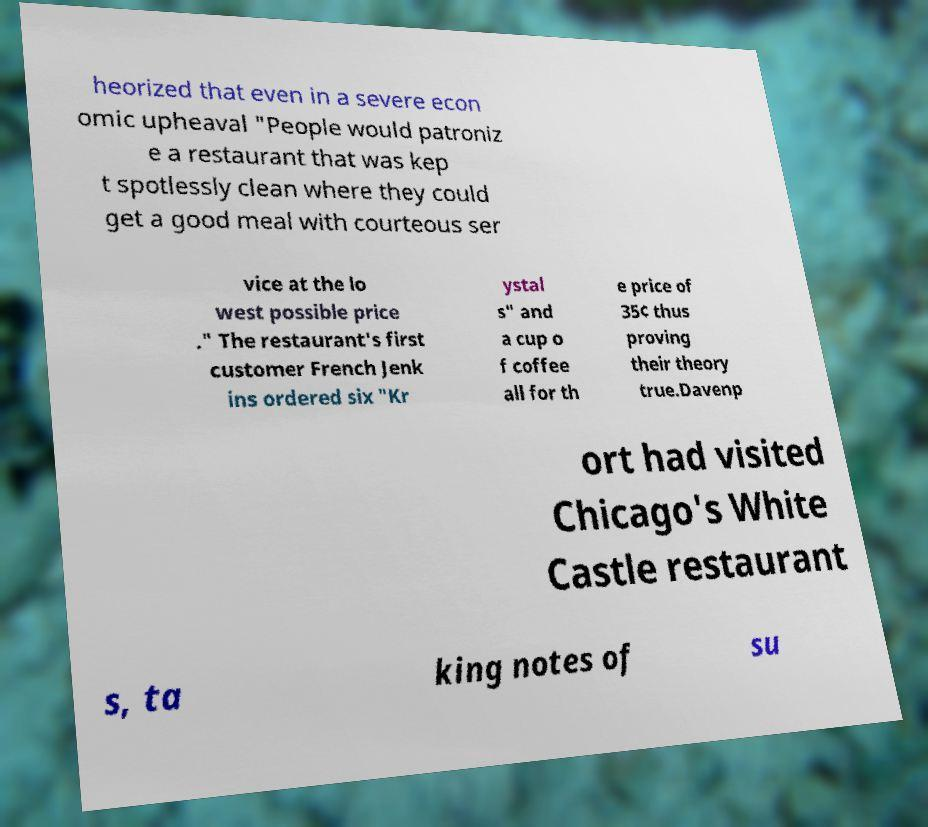Could you extract and type out the text from this image? heorized that even in a severe econ omic upheaval "People would patroniz e a restaurant that was kep t spotlessly clean where they could get a good meal with courteous ser vice at the lo west possible price ." The restaurant's first customer French Jenk ins ordered six "Kr ystal s" and a cup o f coffee all for th e price of 35¢ thus proving their theory true.Davenp ort had visited Chicago's White Castle restaurant s, ta king notes of su 